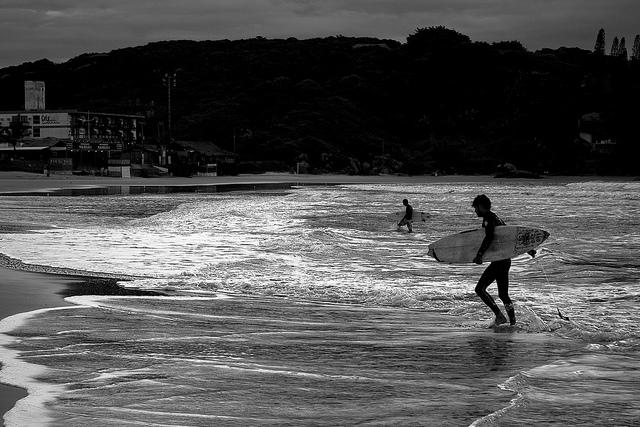What is the problem with this photo? Please explain your reasoning. too dark. This picture is too dark because you have troubles seeing every detail 